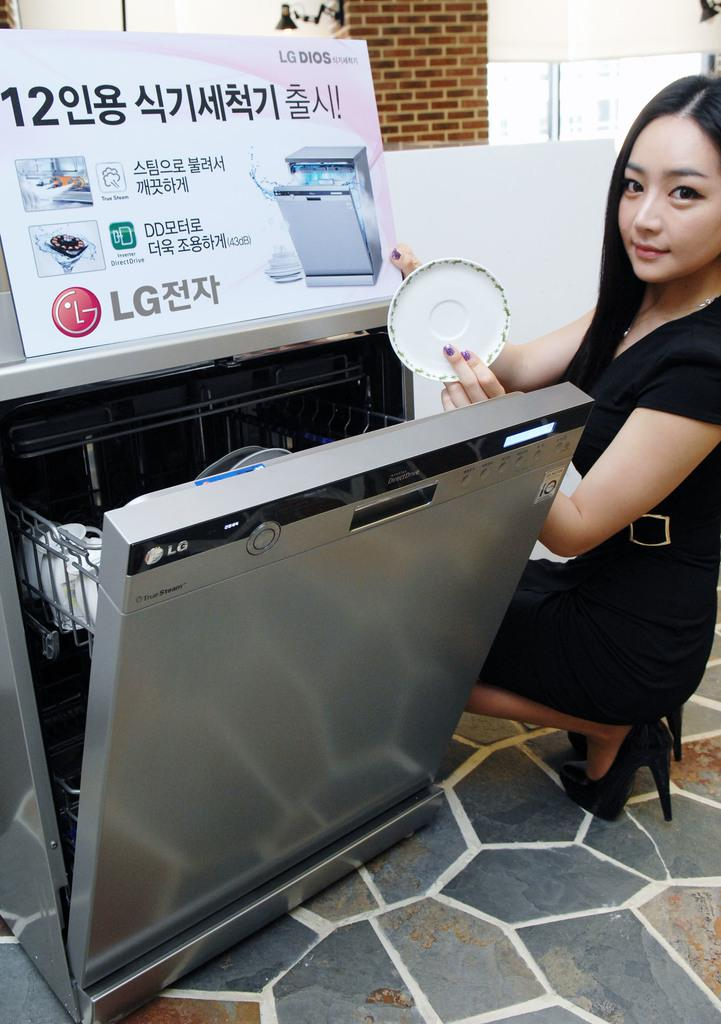<image>
Describe the image concisely. a lady next to a sign that says LG 